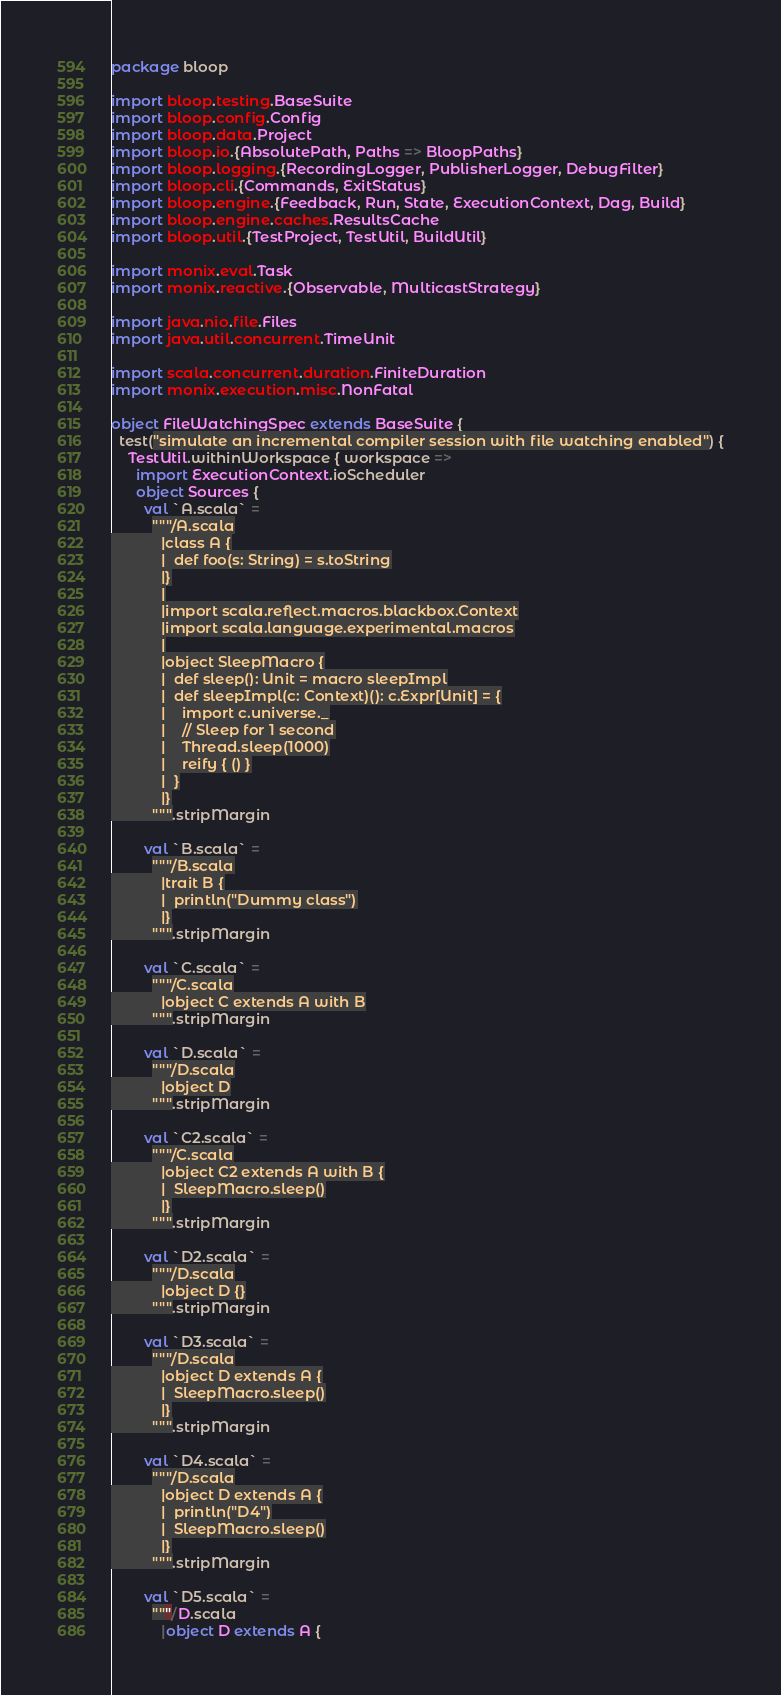<code> <loc_0><loc_0><loc_500><loc_500><_Scala_>package bloop

import bloop.testing.BaseSuite
import bloop.config.Config
import bloop.data.Project
import bloop.io.{AbsolutePath, Paths => BloopPaths}
import bloop.logging.{RecordingLogger, PublisherLogger, DebugFilter}
import bloop.cli.{Commands, ExitStatus}
import bloop.engine.{Feedback, Run, State, ExecutionContext, Dag, Build}
import bloop.engine.caches.ResultsCache
import bloop.util.{TestProject, TestUtil, BuildUtil}

import monix.eval.Task
import monix.reactive.{Observable, MulticastStrategy}

import java.nio.file.Files
import java.util.concurrent.TimeUnit

import scala.concurrent.duration.FiniteDuration
import monix.execution.misc.NonFatal

object FileWatchingSpec extends BaseSuite {
  test("simulate an incremental compiler session with file watching enabled") {
    TestUtil.withinWorkspace { workspace =>
      import ExecutionContext.ioScheduler
      object Sources {
        val `A.scala` =
          """/A.scala
            |class A {
            |  def foo(s: String) = s.toString
            |}
            |
            |import scala.reflect.macros.blackbox.Context
            |import scala.language.experimental.macros
            |
            |object SleepMacro {
            |  def sleep(): Unit = macro sleepImpl
            |  def sleepImpl(c: Context)(): c.Expr[Unit] = {
            |    import c.universe._
            |    // Sleep for 1 second
            |    Thread.sleep(1000)
            |    reify { () }
            |  }
            |}
          """.stripMargin

        val `B.scala` =
          """/B.scala
            |trait B {
            |  println("Dummy class")
            |}
          """.stripMargin

        val `C.scala` =
          """/C.scala
            |object C extends A with B
          """.stripMargin

        val `D.scala` =
          """/D.scala
            |object D
          """.stripMargin

        val `C2.scala` =
          """/C.scala
            |object C2 extends A with B {
            |  SleepMacro.sleep()
            |}
          """.stripMargin

        val `D2.scala` =
          """/D.scala
            |object D {}
          """.stripMargin

        val `D3.scala` =
          """/D.scala
            |object D extends A {
            |  SleepMacro.sleep()
            |}
          """.stripMargin

        val `D4.scala` =
          """/D.scala
            |object D extends A {
            |  println("D4")
            |  SleepMacro.sleep()
            |}
          """.stripMargin

        val `D5.scala` =
          """/D.scala
            |object D extends A {</code> 